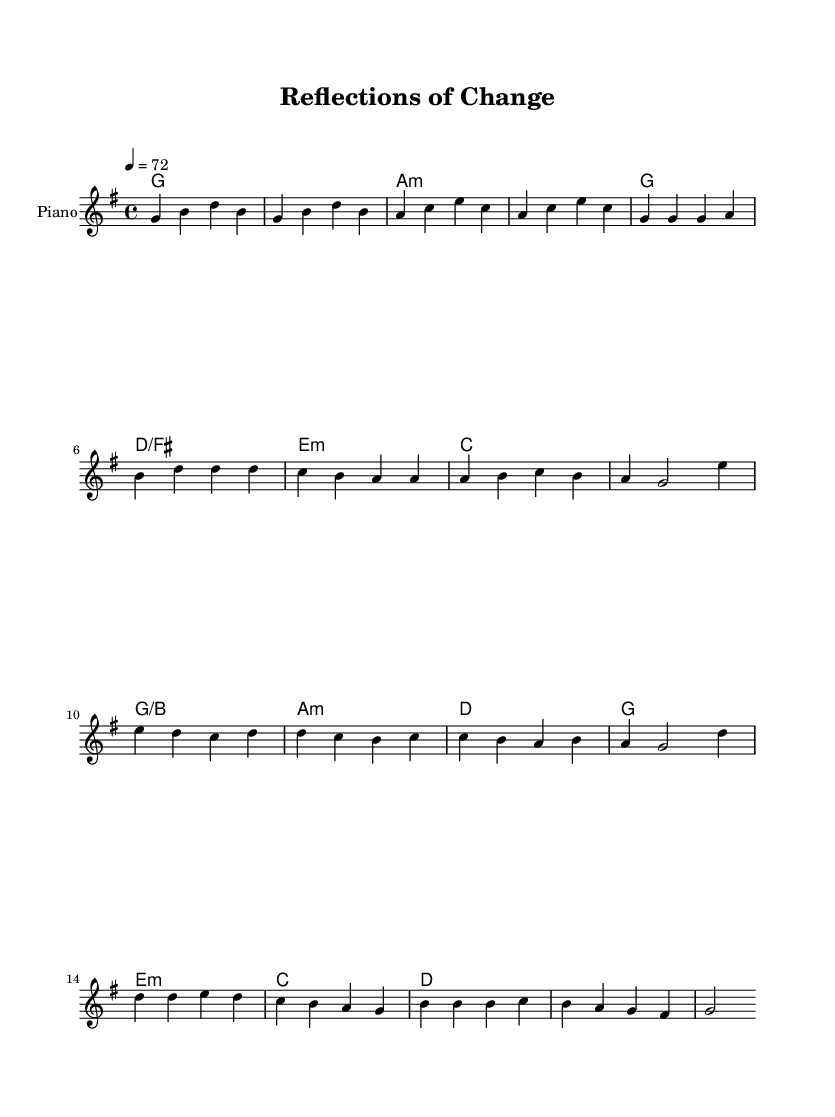What is the key signature of this music? The key signature is G major, which has one sharp (F#). It can be identified at the beginning of the score where the sharp is placed on the F line of the staff.
Answer: G major What is the time signature of this music? The time signature is 4/4, which can be found at the beginning of the score before the notes start. It indicates that there are four beats in each measure and the quarter note gets one beat.
Answer: 4/4 What is the tempo marking for this piece? The tempo marking is 72 BPM, which is specified in the score. It indicates that there are 72 beats per minute, providing a moderate pace for the performance of the piece.
Answer: 72 How many measures are in the chorus section of the song? The chorus section consists of 4 measures, as indicated by the grouping of notes and corresponding chord symbols within the score. Each measure is separated by vertical lines, and there are four such groups in the chorus.
Answer: 4 What type of chord is played during the pre-chorus? The chords in the pre-chorus include C major, G/B, A minor, and D major. This tells us that the pre-chorus features a mix of major and minor quality chords that typically build tension leading into the chorus.
Answer: C, G/B, A minor, D What is the starting note of the melody in the verse? The starting note of the melody in the verse is G. This can be found at the beginning of the verse section where the notes are laid out in a sequence.
Answer: G How many unique notes are used in the chorus? There are 6 unique notes used in the chorus: D, E, C, B, A, and G. This can be determined by reviewing the melody line in the chorus section and identifying the distinct pitches without repetition.
Answer: 6 